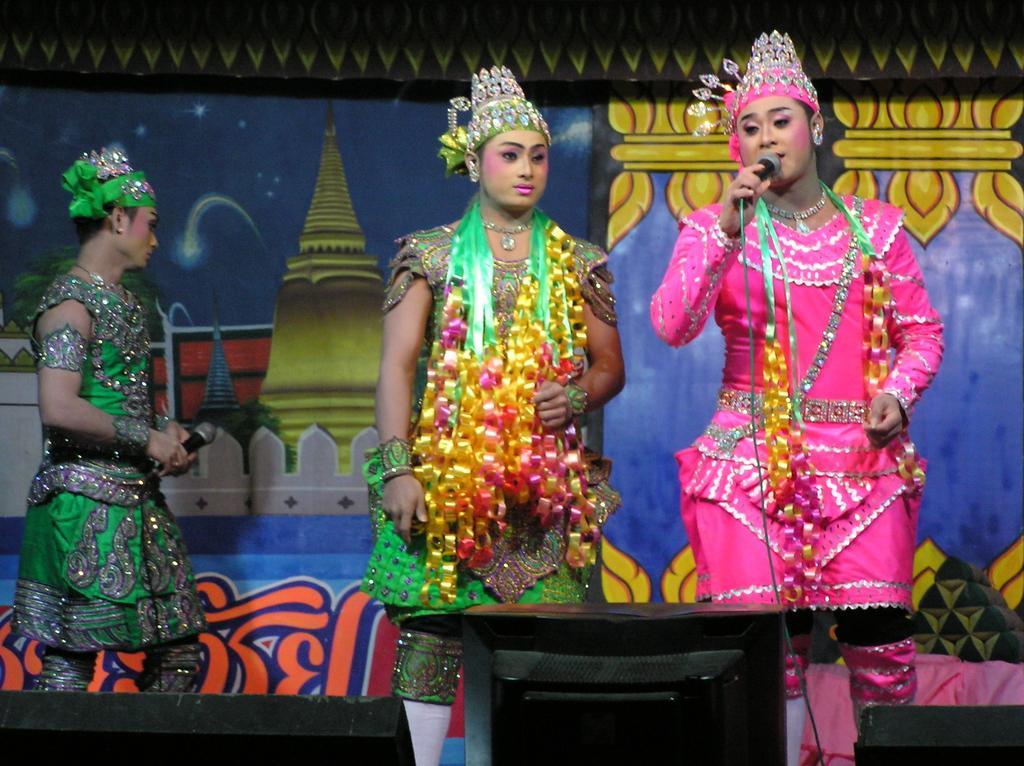In one or two sentences, can you explain what this image depicts? In the image we can see three people standing, wearing clothes, neck chain, crown and earrings. Two of them are holding a microphone in their hand, here we can see a poster and a cable wire. 